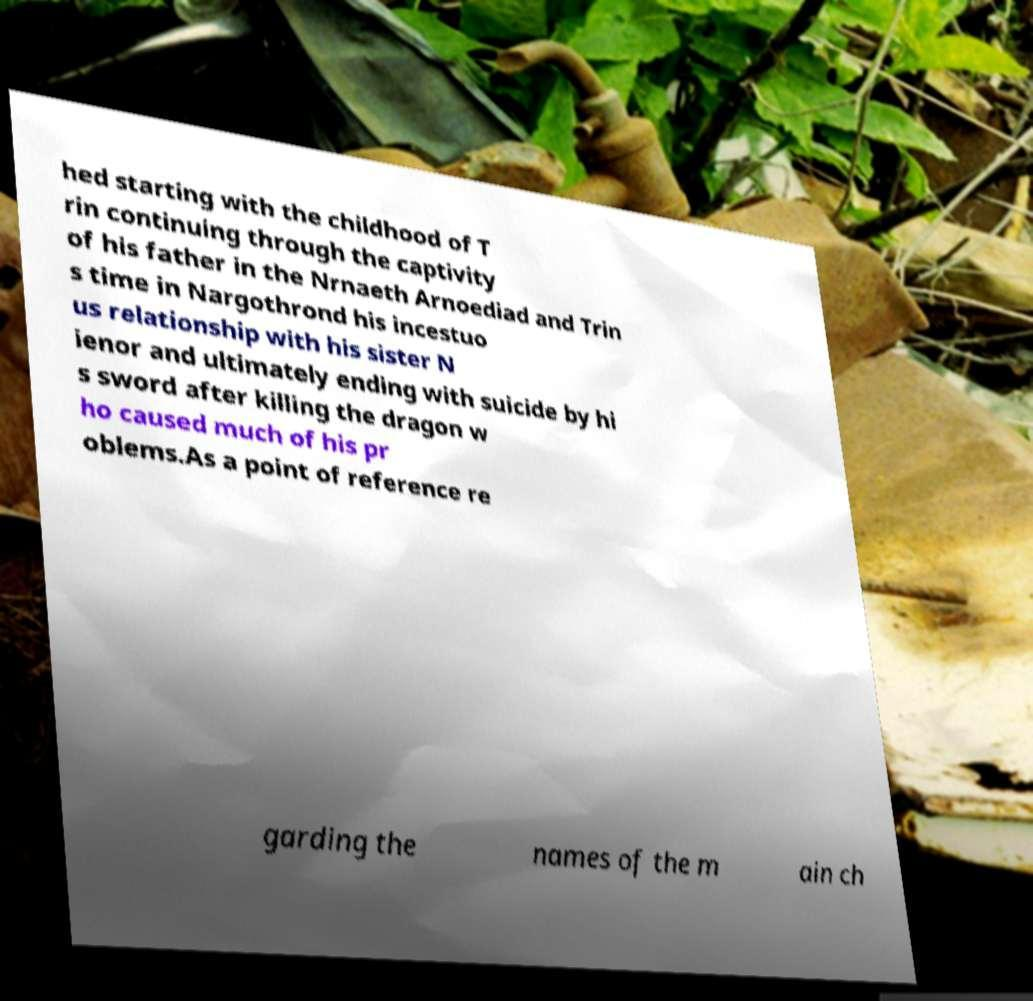I need the written content from this picture converted into text. Can you do that? hed starting with the childhood of T rin continuing through the captivity of his father in the Nrnaeth Arnoediad and Trin s time in Nargothrond his incestuo us relationship with his sister N ienor and ultimately ending with suicide by hi s sword after killing the dragon w ho caused much of his pr oblems.As a point of reference re garding the names of the m ain ch 